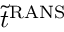<formula> <loc_0><loc_0><loc_500><loc_500>\tilde { t } ^ { R A N S }</formula> 